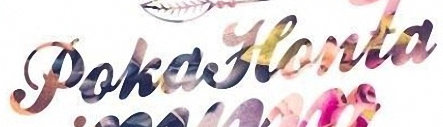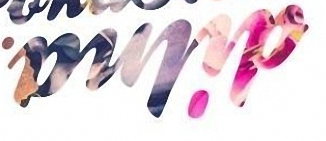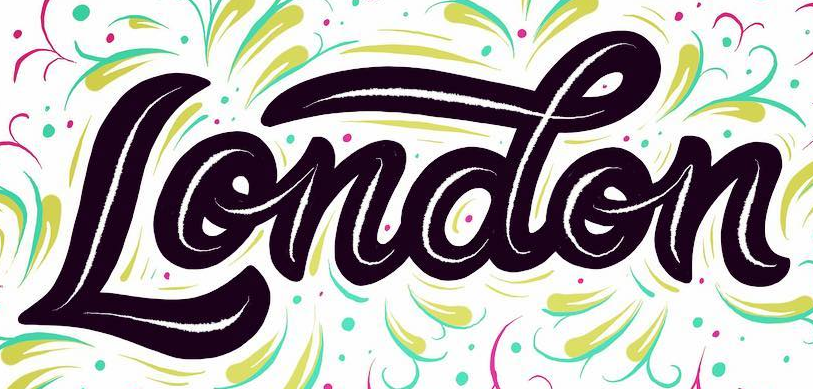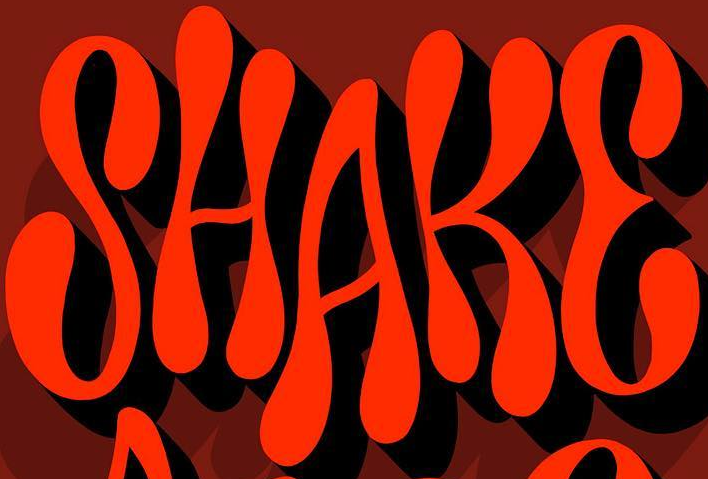What words can you see in these images in sequence, separated by a semicolon? PokaHonta; dilna; London; SHAKE 